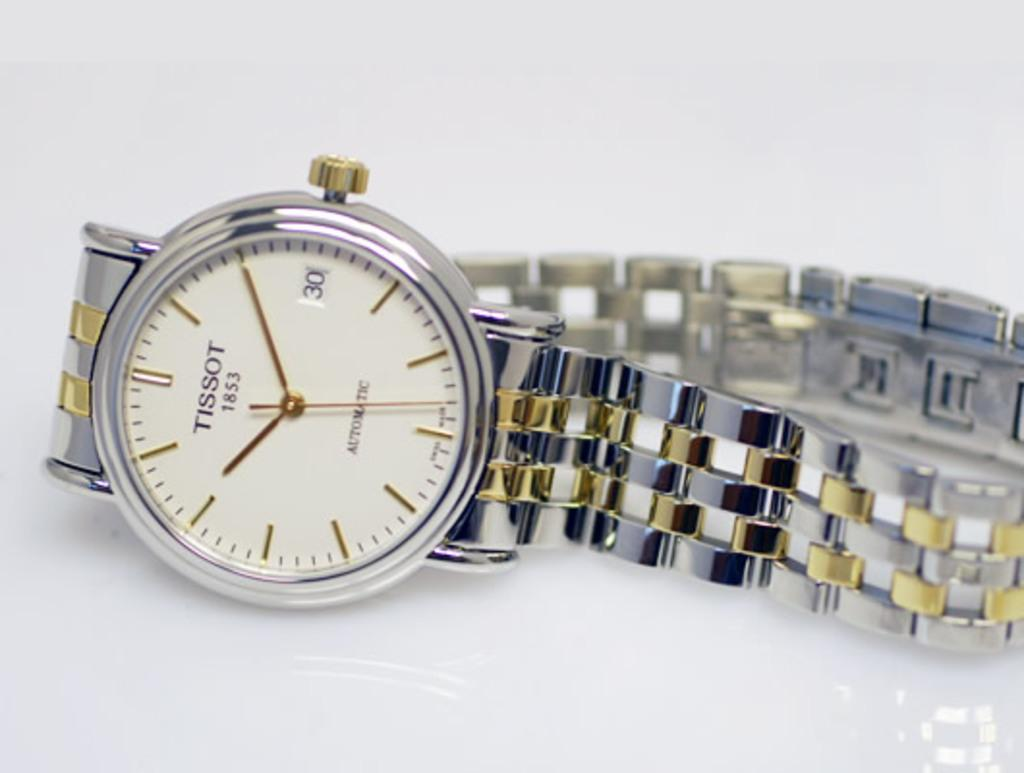<image>
Create a compact narrative representing the image presented. A watch with gold and silver links and the word Tissot on the top. 